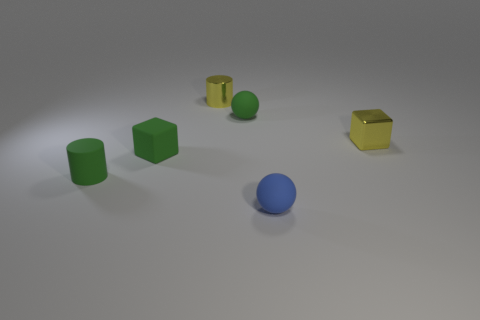Subtract all yellow cylinders. How many red blocks are left? 0 Subtract all yellow shiny spheres. Subtract all tiny shiny cylinders. How many objects are left? 5 Add 4 tiny green cylinders. How many tiny green cylinders are left? 5 Add 5 small green cylinders. How many small green cylinders exist? 6 Add 3 small green rubber cylinders. How many objects exist? 9 Subtract all green balls. How many balls are left? 1 Subtract 0 brown cubes. How many objects are left? 6 Subtract all cylinders. How many objects are left? 4 Subtract 1 balls. How many balls are left? 1 Subtract all yellow cylinders. Subtract all blue blocks. How many cylinders are left? 1 